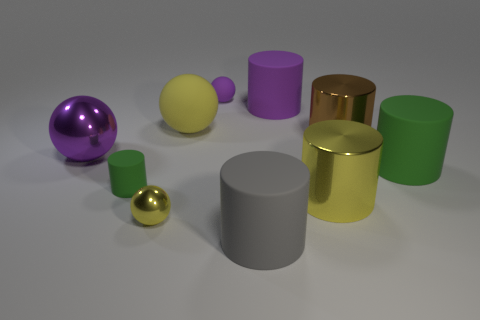Subtract all green cylinders. How many cylinders are left? 4 Subtract all purple cylinders. How many cylinders are left? 5 Subtract all cyan cylinders. Subtract all gray spheres. How many cylinders are left? 6 Subtract all spheres. How many objects are left? 6 Add 4 tiny yellow metallic cylinders. How many tiny yellow metallic cylinders exist? 4 Subtract 0 brown balls. How many objects are left? 10 Subtract all blue objects. Subtract all yellow spheres. How many objects are left? 8 Add 5 big gray matte cylinders. How many big gray matte cylinders are left? 6 